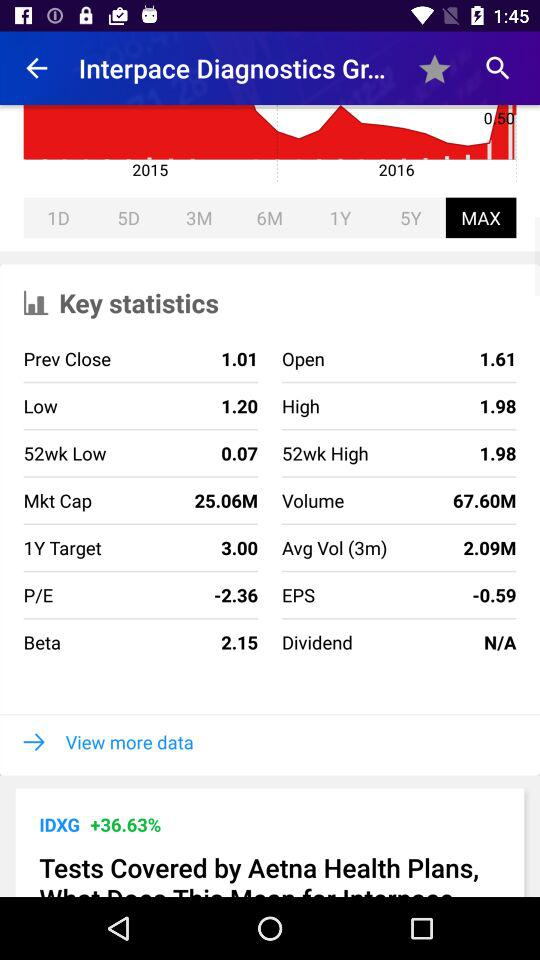What is the difference between the 52-week high and the 52-week low?
Answer the question using a single word or phrase. 1.91 